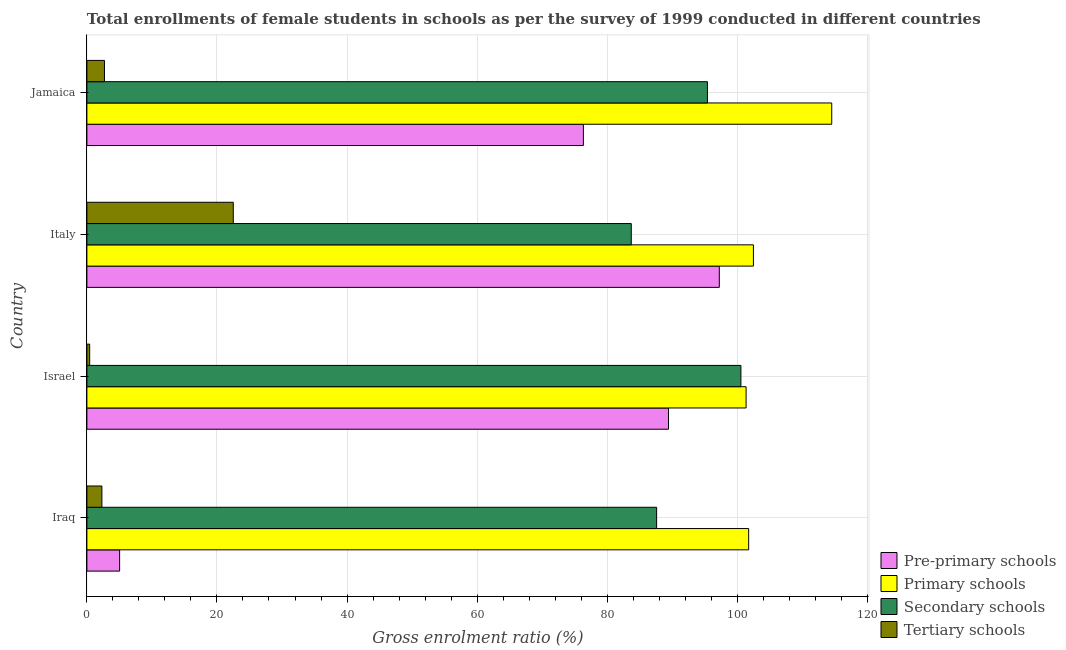Are the number of bars per tick equal to the number of legend labels?
Provide a short and direct response. Yes. How many bars are there on the 2nd tick from the top?
Give a very brief answer. 4. How many bars are there on the 1st tick from the bottom?
Offer a terse response. 4. What is the label of the 1st group of bars from the top?
Your response must be concise. Jamaica. What is the gross enrolment ratio(female) in secondary schools in Iraq?
Offer a very short reply. 87.61. Across all countries, what is the maximum gross enrolment ratio(female) in secondary schools?
Your response must be concise. 100.57. Across all countries, what is the minimum gross enrolment ratio(female) in primary schools?
Offer a very short reply. 101.37. In which country was the gross enrolment ratio(female) in secondary schools maximum?
Your answer should be very brief. Israel. What is the total gross enrolment ratio(female) in primary schools in the graph?
Provide a short and direct response. 420.15. What is the difference between the gross enrolment ratio(female) in secondary schools in Italy and that in Jamaica?
Offer a very short reply. -11.71. What is the difference between the gross enrolment ratio(female) in pre-primary schools in Jamaica and the gross enrolment ratio(female) in tertiary schools in Italy?
Provide a succinct answer. 53.84. What is the average gross enrolment ratio(female) in primary schools per country?
Ensure brevity in your answer.  105.04. What is the difference between the gross enrolment ratio(female) in pre-primary schools and gross enrolment ratio(female) in primary schools in Italy?
Your response must be concise. -5.24. What is the ratio of the gross enrolment ratio(female) in secondary schools in Iraq to that in Italy?
Your answer should be compact. 1.05. Is the gross enrolment ratio(female) in primary schools in Israel less than that in Italy?
Ensure brevity in your answer.  Yes. What is the difference between the highest and the second highest gross enrolment ratio(female) in primary schools?
Provide a succinct answer. 12.04. What is the difference between the highest and the lowest gross enrolment ratio(female) in secondary schools?
Offer a very short reply. 16.86. In how many countries, is the gross enrolment ratio(female) in tertiary schools greater than the average gross enrolment ratio(female) in tertiary schools taken over all countries?
Your response must be concise. 1. Is the sum of the gross enrolment ratio(female) in pre-primary schools in Iraq and Israel greater than the maximum gross enrolment ratio(female) in tertiary schools across all countries?
Provide a short and direct response. Yes. What does the 2nd bar from the top in Iraq represents?
Your answer should be very brief. Secondary schools. What does the 1st bar from the bottom in Israel represents?
Provide a succinct answer. Pre-primary schools. Is it the case that in every country, the sum of the gross enrolment ratio(female) in pre-primary schools and gross enrolment ratio(female) in primary schools is greater than the gross enrolment ratio(female) in secondary schools?
Keep it short and to the point. Yes. How many bars are there?
Offer a terse response. 16. Where does the legend appear in the graph?
Your answer should be very brief. Bottom right. How are the legend labels stacked?
Provide a short and direct response. Vertical. What is the title of the graph?
Provide a succinct answer. Total enrollments of female students in schools as per the survey of 1999 conducted in different countries. Does "Ease of arranging shipments" appear as one of the legend labels in the graph?
Offer a very short reply. No. What is the Gross enrolment ratio (%) of Pre-primary schools in Iraq?
Your answer should be very brief. 5.03. What is the Gross enrolment ratio (%) of Primary schools in Iraq?
Provide a short and direct response. 101.76. What is the Gross enrolment ratio (%) in Secondary schools in Iraq?
Offer a very short reply. 87.61. What is the Gross enrolment ratio (%) in Tertiary schools in Iraq?
Keep it short and to the point. 2.31. What is the Gross enrolment ratio (%) in Pre-primary schools in Israel?
Provide a succinct answer. 89.43. What is the Gross enrolment ratio (%) in Primary schools in Israel?
Keep it short and to the point. 101.37. What is the Gross enrolment ratio (%) in Secondary schools in Israel?
Make the answer very short. 100.57. What is the Gross enrolment ratio (%) in Tertiary schools in Israel?
Ensure brevity in your answer.  0.43. What is the Gross enrolment ratio (%) in Pre-primary schools in Italy?
Your response must be concise. 97.25. What is the Gross enrolment ratio (%) of Primary schools in Italy?
Offer a terse response. 102.49. What is the Gross enrolment ratio (%) in Secondary schools in Italy?
Provide a short and direct response. 83.71. What is the Gross enrolment ratio (%) in Tertiary schools in Italy?
Provide a succinct answer. 22.51. What is the Gross enrolment ratio (%) in Pre-primary schools in Jamaica?
Provide a short and direct response. 76.35. What is the Gross enrolment ratio (%) of Primary schools in Jamaica?
Your answer should be very brief. 114.53. What is the Gross enrolment ratio (%) in Secondary schools in Jamaica?
Offer a terse response. 95.42. What is the Gross enrolment ratio (%) in Tertiary schools in Jamaica?
Provide a succinct answer. 2.7. Across all countries, what is the maximum Gross enrolment ratio (%) of Pre-primary schools?
Make the answer very short. 97.25. Across all countries, what is the maximum Gross enrolment ratio (%) of Primary schools?
Offer a terse response. 114.53. Across all countries, what is the maximum Gross enrolment ratio (%) of Secondary schools?
Give a very brief answer. 100.57. Across all countries, what is the maximum Gross enrolment ratio (%) of Tertiary schools?
Give a very brief answer. 22.51. Across all countries, what is the minimum Gross enrolment ratio (%) in Pre-primary schools?
Keep it short and to the point. 5.03. Across all countries, what is the minimum Gross enrolment ratio (%) in Primary schools?
Your answer should be very brief. 101.37. Across all countries, what is the minimum Gross enrolment ratio (%) in Secondary schools?
Ensure brevity in your answer.  83.71. Across all countries, what is the minimum Gross enrolment ratio (%) in Tertiary schools?
Your answer should be compact. 0.43. What is the total Gross enrolment ratio (%) of Pre-primary schools in the graph?
Ensure brevity in your answer.  268.06. What is the total Gross enrolment ratio (%) of Primary schools in the graph?
Your response must be concise. 420.15. What is the total Gross enrolment ratio (%) of Secondary schools in the graph?
Offer a terse response. 367.3. What is the total Gross enrolment ratio (%) of Tertiary schools in the graph?
Offer a terse response. 27.95. What is the difference between the Gross enrolment ratio (%) in Pre-primary schools in Iraq and that in Israel?
Provide a short and direct response. -84.4. What is the difference between the Gross enrolment ratio (%) in Primary schools in Iraq and that in Israel?
Keep it short and to the point. 0.39. What is the difference between the Gross enrolment ratio (%) of Secondary schools in Iraq and that in Israel?
Provide a succinct answer. -12.96. What is the difference between the Gross enrolment ratio (%) of Tertiary schools in Iraq and that in Israel?
Keep it short and to the point. 1.88. What is the difference between the Gross enrolment ratio (%) in Pre-primary schools in Iraq and that in Italy?
Keep it short and to the point. -92.22. What is the difference between the Gross enrolment ratio (%) of Primary schools in Iraq and that in Italy?
Your response must be concise. -0.73. What is the difference between the Gross enrolment ratio (%) in Secondary schools in Iraq and that in Italy?
Your response must be concise. 3.9. What is the difference between the Gross enrolment ratio (%) of Tertiary schools in Iraq and that in Italy?
Your answer should be very brief. -20.2. What is the difference between the Gross enrolment ratio (%) in Pre-primary schools in Iraq and that in Jamaica?
Your answer should be compact. -71.31. What is the difference between the Gross enrolment ratio (%) in Primary schools in Iraq and that in Jamaica?
Your response must be concise. -12.77. What is the difference between the Gross enrolment ratio (%) in Secondary schools in Iraq and that in Jamaica?
Your answer should be compact. -7.81. What is the difference between the Gross enrolment ratio (%) of Tertiary schools in Iraq and that in Jamaica?
Offer a terse response. -0.39. What is the difference between the Gross enrolment ratio (%) in Pre-primary schools in Israel and that in Italy?
Your response must be concise. -7.82. What is the difference between the Gross enrolment ratio (%) of Primary schools in Israel and that in Italy?
Keep it short and to the point. -1.13. What is the difference between the Gross enrolment ratio (%) of Secondary schools in Israel and that in Italy?
Ensure brevity in your answer.  16.86. What is the difference between the Gross enrolment ratio (%) of Tertiary schools in Israel and that in Italy?
Offer a very short reply. -22.08. What is the difference between the Gross enrolment ratio (%) in Pre-primary schools in Israel and that in Jamaica?
Your answer should be compact. 13.08. What is the difference between the Gross enrolment ratio (%) of Primary schools in Israel and that in Jamaica?
Your answer should be very brief. -13.17. What is the difference between the Gross enrolment ratio (%) in Secondary schools in Israel and that in Jamaica?
Provide a succinct answer. 5.15. What is the difference between the Gross enrolment ratio (%) of Tertiary schools in Israel and that in Jamaica?
Provide a short and direct response. -2.27. What is the difference between the Gross enrolment ratio (%) of Pre-primary schools in Italy and that in Jamaica?
Your answer should be very brief. 20.9. What is the difference between the Gross enrolment ratio (%) of Primary schools in Italy and that in Jamaica?
Offer a terse response. -12.04. What is the difference between the Gross enrolment ratio (%) of Secondary schools in Italy and that in Jamaica?
Provide a succinct answer. -11.71. What is the difference between the Gross enrolment ratio (%) in Tertiary schools in Italy and that in Jamaica?
Your response must be concise. 19.81. What is the difference between the Gross enrolment ratio (%) of Pre-primary schools in Iraq and the Gross enrolment ratio (%) of Primary schools in Israel?
Your answer should be very brief. -96.33. What is the difference between the Gross enrolment ratio (%) of Pre-primary schools in Iraq and the Gross enrolment ratio (%) of Secondary schools in Israel?
Make the answer very short. -95.53. What is the difference between the Gross enrolment ratio (%) of Pre-primary schools in Iraq and the Gross enrolment ratio (%) of Tertiary schools in Israel?
Make the answer very short. 4.6. What is the difference between the Gross enrolment ratio (%) in Primary schools in Iraq and the Gross enrolment ratio (%) in Secondary schools in Israel?
Provide a succinct answer. 1.19. What is the difference between the Gross enrolment ratio (%) of Primary schools in Iraq and the Gross enrolment ratio (%) of Tertiary schools in Israel?
Offer a terse response. 101.33. What is the difference between the Gross enrolment ratio (%) in Secondary schools in Iraq and the Gross enrolment ratio (%) in Tertiary schools in Israel?
Offer a terse response. 87.18. What is the difference between the Gross enrolment ratio (%) of Pre-primary schools in Iraq and the Gross enrolment ratio (%) of Primary schools in Italy?
Your answer should be compact. -97.46. What is the difference between the Gross enrolment ratio (%) of Pre-primary schools in Iraq and the Gross enrolment ratio (%) of Secondary schools in Italy?
Provide a succinct answer. -78.68. What is the difference between the Gross enrolment ratio (%) of Pre-primary schools in Iraq and the Gross enrolment ratio (%) of Tertiary schools in Italy?
Your response must be concise. -17.48. What is the difference between the Gross enrolment ratio (%) of Primary schools in Iraq and the Gross enrolment ratio (%) of Secondary schools in Italy?
Provide a short and direct response. 18.05. What is the difference between the Gross enrolment ratio (%) of Primary schools in Iraq and the Gross enrolment ratio (%) of Tertiary schools in Italy?
Keep it short and to the point. 79.25. What is the difference between the Gross enrolment ratio (%) in Secondary schools in Iraq and the Gross enrolment ratio (%) in Tertiary schools in Italy?
Make the answer very short. 65.1. What is the difference between the Gross enrolment ratio (%) in Pre-primary schools in Iraq and the Gross enrolment ratio (%) in Primary schools in Jamaica?
Provide a short and direct response. -109.5. What is the difference between the Gross enrolment ratio (%) in Pre-primary schools in Iraq and the Gross enrolment ratio (%) in Secondary schools in Jamaica?
Ensure brevity in your answer.  -90.39. What is the difference between the Gross enrolment ratio (%) of Pre-primary schools in Iraq and the Gross enrolment ratio (%) of Tertiary schools in Jamaica?
Make the answer very short. 2.33. What is the difference between the Gross enrolment ratio (%) in Primary schools in Iraq and the Gross enrolment ratio (%) in Secondary schools in Jamaica?
Provide a succinct answer. 6.34. What is the difference between the Gross enrolment ratio (%) in Primary schools in Iraq and the Gross enrolment ratio (%) in Tertiary schools in Jamaica?
Make the answer very short. 99.06. What is the difference between the Gross enrolment ratio (%) in Secondary schools in Iraq and the Gross enrolment ratio (%) in Tertiary schools in Jamaica?
Offer a terse response. 84.91. What is the difference between the Gross enrolment ratio (%) in Pre-primary schools in Israel and the Gross enrolment ratio (%) in Primary schools in Italy?
Ensure brevity in your answer.  -13.06. What is the difference between the Gross enrolment ratio (%) in Pre-primary schools in Israel and the Gross enrolment ratio (%) in Secondary schools in Italy?
Provide a succinct answer. 5.72. What is the difference between the Gross enrolment ratio (%) in Pre-primary schools in Israel and the Gross enrolment ratio (%) in Tertiary schools in Italy?
Ensure brevity in your answer.  66.92. What is the difference between the Gross enrolment ratio (%) of Primary schools in Israel and the Gross enrolment ratio (%) of Secondary schools in Italy?
Provide a succinct answer. 17.66. What is the difference between the Gross enrolment ratio (%) of Primary schools in Israel and the Gross enrolment ratio (%) of Tertiary schools in Italy?
Provide a short and direct response. 78.86. What is the difference between the Gross enrolment ratio (%) in Secondary schools in Israel and the Gross enrolment ratio (%) in Tertiary schools in Italy?
Your response must be concise. 78.06. What is the difference between the Gross enrolment ratio (%) in Pre-primary schools in Israel and the Gross enrolment ratio (%) in Primary schools in Jamaica?
Provide a short and direct response. -25.1. What is the difference between the Gross enrolment ratio (%) in Pre-primary schools in Israel and the Gross enrolment ratio (%) in Secondary schools in Jamaica?
Offer a very short reply. -5.99. What is the difference between the Gross enrolment ratio (%) in Pre-primary schools in Israel and the Gross enrolment ratio (%) in Tertiary schools in Jamaica?
Your response must be concise. 86.73. What is the difference between the Gross enrolment ratio (%) of Primary schools in Israel and the Gross enrolment ratio (%) of Secondary schools in Jamaica?
Keep it short and to the point. 5.94. What is the difference between the Gross enrolment ratio (%) in Primary schools in Israel and the Gross enrolment ratio (%) in Tertiary schools in Jamaica?
Make the answer very short. 98.66. What is the difference between the Gross enrolment ratio (%) of Secondary schools in Israel and the Gross enrolment ratio (%) of Tertiary schools in Jamaica?
Make the answer very short. 97.87. What is the difference between the Gross enrolment ratio (%) in Pre-primary schools in Italy and the Gross enrolment ratio (%) in Primary schools in Jamaica?
Your response must be concise. -17.29. What is the difference between the Gross enrolment ratio (%) in Pre-primary schools in Italy and the Gross enrolment ratio (%) in Secondary schools in Jamaica?
Give a very brief answer. 1.83. What is the difference between the Gross enrolment ratio (%) of Pre-primary schools in Italy and the Gross enrolment ratio (%) of Tertiary schools in Jamaica?
Offer a terse response. 94.55. What is the difference between the Gross enrolment ratio (%) in Primary schools in Italy and the Gross enrolment ratio (%) in Secondary schools in Jamaica?
Make the answer very short. 7.07. What is the difference between the Gross enrolment ratio (%) in Primary schools in Italy and the Gross enrolment ratio (%) in Tertiary schools in Jamaica?
Provide a succinct answer. 99.79. What is the difference between the Gross enrolment ratio (%) in Secondary schools in Italy and the Gross enrolment ratio (%) in Tertiary schools in Jamaica?
Make the answer very short. 81.01. What is the average Gross enrolment ratio (%) of Pre-primary schools per country?
Offer a very short reply. 67.01. What is the average Gross enrolment ratio (%) of Primary schools per country?
Give a very brief answer. 105.04. What is the average Gross enrolment ratio (%) in Secondary schools per country?
Your answer should be very brief. 91.83. What is the average Gross enrolment ratio (%) of Tertiary schools per country?
Provide a short and direct response. 6.99. What is the difference between the Gross enrolment ratio (%) in Pre-primary schools and Gross enrolment ratio (%) in Primary schools in Iraq?
Your answer should be very brief. -96.73. What is the difference between the Gross enrolment ratio (%) of Pre-primary schools and Gross enrolment ratio (%) of Secondary schools in Iraq?
Your response must be concise. -82.58. What is the difference between the Gross enrolment ratio (%) in Pre-primary schools and Gross enrolment ratio (%) in Tertiary schools in Iraq?
Offer a very short reply. 2.73. What is the difference between the Gross enrolment ratio (%) in Primary schools and Gross enrolment ratio (%) in Secondary schools in Iraq?
Your answer should be compact. 14.15. What is the difference between the Gross enrolment ratio (%) of Primary schools and Gross enrolment ratio (%) of Tertiary schools in Iraq?
Offer a terse response. 99.45. What is the difference between the Gross enrolment ratio (%) of Secondary schools and Gross enrolment ratio (%) of Tertiary schools in Iraq?
Give a very brief answer. 85.3. What is the difference between the Gross enrolment ratio (%) in Pre-primary schools and Gross enrolment ratio (%) in Primary schools in Israel?
Ensure brevity in your answer.  -11.93. What is the difference between the Gross enrolment ratio (%) in Pre-primary schools and Gross enrolment ratio (%) in Secondary schools in Israel?
Offer a terse response. -11.14. What is the difference between the Gross enrolment ratio (%) of Pre-primary schools and Gross enrolment ratio (%) of Tertiary schools in Israel?
Ensure brevity in your answer.  89. What is the difference between the Gross enrolment ratio (%) in Primary schools and Gross enrolment ratio (%) in Secondary schools in Israel?
Ensure brevity in your answer.  0.8. What is the difference between the Gross enrolment ratio (%) of Primary schools and Gross enrolment ratio (%) of Tertiary schools in Israel?
Give a very brief answer. 100.94. What is the difference between the Gross enrolment ratio (%) of Secondary schools and Gross enrolment ratio (%) of Tertiary schools in Israel?
Ensure brevity in your answer.  100.14. What is the difference between the Gross enrolment ratio (%) of Pre-primary schools and Gross enrolment ratio (%) of Primary schools in Italy?
Make the answer very short. -5.24. What is the difference between the Gross enrolment ratio (%) of Pre-primary schools and Gross enrolment ratio (%) of Secondary schools in Italy?
Ensure brevity in your answer.  13.54. What is the difference between the Gross enrolment ratio (%) of Pre-primary schools and Gross enrolment ratio (%) of Tertiary schools in Italy?
Provide a short and direct response. 74.74. What is the difference between the Gross enrolment ratio (%) of Primary schools and Gross enrolment ratio (%) of Secondary schools in Italy?
Offer a very short reply. 18.78. What is the difference between the Gross enrolment ratio (%) of Primary schools and Gross enrolment ratio (%) of Tertiary schools in Italy?
Make the answer very short. 79.98. What is the difference between the Gross enrolment ratio (%) in Secondary schools and Gross enrolment ratio (%) in Tertiary schools in Italy?
Keep it short and to the point. 61.2. What is the difference between the Gross enrolment ratio (%) of Pre-primary schools and Gross enrolment ratio (%) of Primary schools in Jamaica?
Provide a short and direct response. -38.19. What is the difference between the Gross enrolment ratio (%) in Pre-primary schools and Gross enrolment ratio (%) in Secondary schools in Jamaica?
Ensure brevity in your answer.  -19.07. What is the difference between the Gross enrolment ratio (%) of Pre-primary schools and Gross enrolment ratio (%) of Tertiary schools in Jamaica?
Offer a very short reply. 73.65. What is the difference between the Gross enrolment ratio (%) in Primary schools and Gross enrolment ratio (%) in Secondary schools in Jamaica?
Your response must be concise. 19.11. What is the difference between the Gross enrolment ratio (%) in Primary schools and Gross enrolment ratio (%) in Tertiary schools in Jamaica?
Keep it short and to the point. 111.83. What is the difference between the Gross enrolment ratio (%) of Secondary schools and Gross enrolment ratio (%) of Tertiary schools in Jamaica?
Offer a terse response. 92.72. What is the ratio of the Gross enrolment ratio (%) in Pre-primary schools in Iraq to that in Israel?
Make the answer very short. 0.06. What is the ratio of the Gross enrolment ratio (%) in Secondary schools in Iraq to that in Israel?
Ensure brevity in your answer.  0.87. What is the ratio of the Gross enrolment ratio (%) in Tertiary schools in Iraq to that in Israel?
Keep it short and to the point. 5.39. What is the ratio of the Gross enrolment ratio (%) in Pre-primary schools in Iraq to that in Italy?
Make the answer very short. 0.05. What is the ratio of the Gross enrolment ratio (%) of Secondary schools in Iraq to that in Italy?
Offer a very short reply. 1.05. What is the ratio of the Gross enrolment ratio (%) of Tertiary schools in Iraq to that in Italy?
Your response must be concise. 0.1. What is the ratio of the Gross enrolment ratio (%) of Pre-primary schools in Iraq to that in Jamaica?
Your response must be concise. 0.07. What is the ratio of the Gross enrolment ratio (%) in Primary schools in Iraq to that in Jamaica?
Provide a succinct answer. 0.89. What is the ratio of the Gross enrolment ratio (%) in Secondary schools in Iraq to that in Jamaica?
Your response must be concise. 0.92. What is the ratio of the Gross enrolment ratio (%) in Tertiary schools in Iraq to that in Jamaica?
Your answer should be compact. 0.85. What is the ratio of the Gross enrolment ratio (%) of Pre-primary schools in Israel to that in Italy?
Offer a terse response. 0.92. What is the ratio of the Gross enrolment ratio (%) in Secondary schools in Israel to that in Italy?
Your answer should be very brief. 1.2. What is the ratio of the Gross enrolment ratio (%) in Tertiary schools in Israel to that in Italy?
Provide a short and direct response. 0.02. What is the ratio of the Gross enrolment ratio (%) in Pre-primary schools in Israel to that in Jamaica?
Your answer should be very brief. 1.17. What is the ratio of the Gross enrolment ratio (%) in Primary schools in Israel to that in Jamaica?
Ensure brevity in your answer.  0.89. What is the ratio of the Gross enrolment ratio (%) of Secondary schools in Israel to that in Jamaica?
Provide a short and direct response. 1.05. What is the ratio of the Gross enrolment ratio (%) in Tertiary schools in Israel to that in Jamaica?
Give a very brief answer. 0.16. What is the ratio of the Gross enrolment ratio (%) of Pre-primary schools in Italy to that in Jamaica?
Give a very brief answer. 1.27. What is the ratio of the Gross enrolment ratio (%) in Primary schools in Italy to that in Jamaica?
Provide a short and direct response. 0.89. What is the ratio of the Gross enrolment ratio (%) of Secondary schools in Italy to that in Jamaica?
Provide a short and direct response. 0.88. What is the ratio of the Gross enrolment ratio (%) in Tertiary schools in Italy to that in Jamaica?
Provide a succinct answer. 8.33. What is the difference between the highest and the second highest Gross enrolment ratio (%) in Pre-primary schools?
Provide a succinct answer. 7.82. What is the difference between the highest and the second highest Gross enrolment ratio (%) in Primary schools?
Provide a succinct answer. 12.04. What is the difference between the highest and the second highest Gross enrolment ratio (%) in Secondary schools?
Provide a succinct answer. 5.15. What is the difference between the highest and the second highest Gross enrolment ratio (%) of Tertiary schools?
Give a very brief answer. 19.81. What is the difference between the highest and the lowest Gross enrolment ratio (%) in Pre-primary schools?
Provide a succinct answer. 92.22. What is the difference between the highest and the lowest Gross enrolment ratio (%) of Primary schools?
Make the answer very short. 13.17. What is the difference between the highest and the lowest Gross enrolment ratio (%) in Secondary schools?
Keep it short and to the point. 16.86. What is the difference between the highest and the lowest Gross enrolment ratio (%) in Tertiary schools?
Provide a short and direct response. 22.08. 